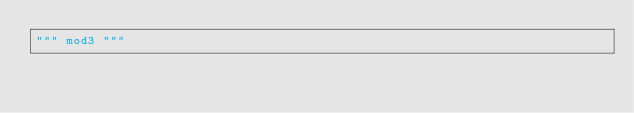<code> <loc_0><loc_0><loc_500><loc_500><_Python_>""" mod3 """
</code> 